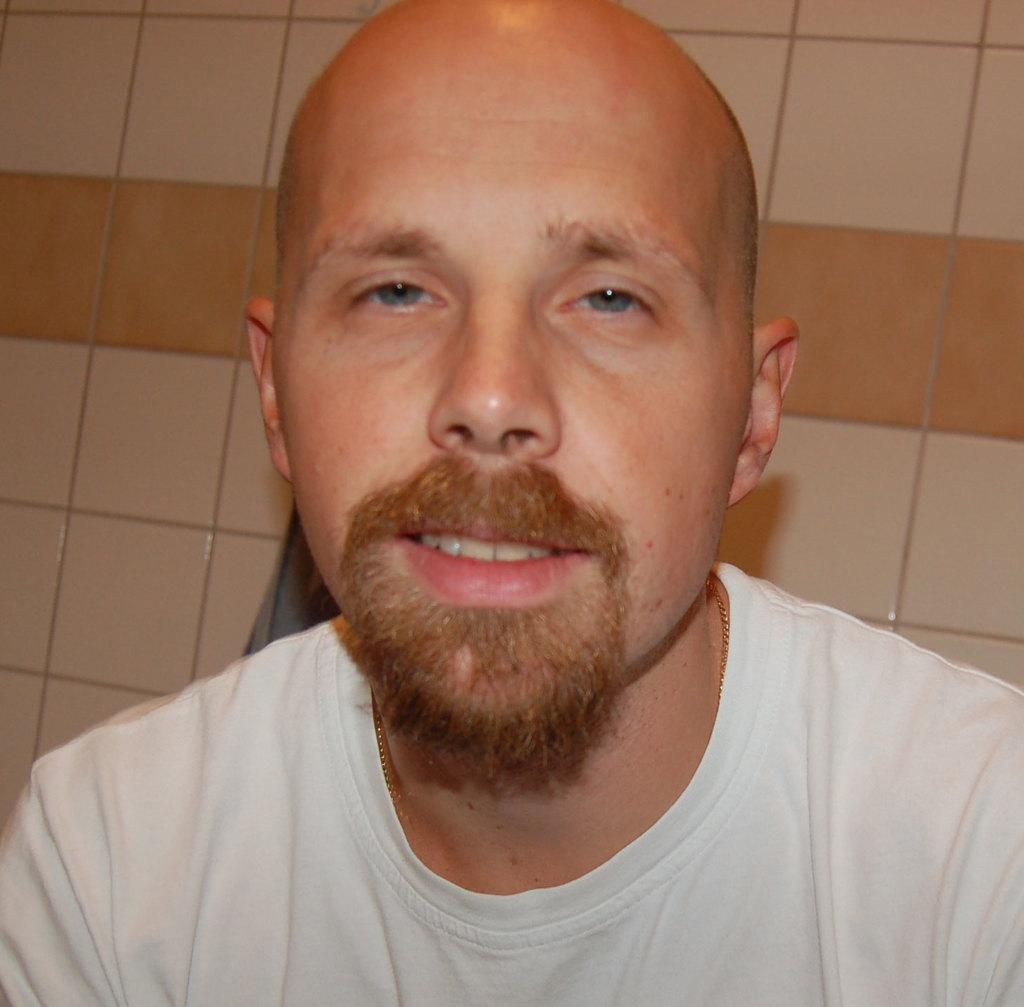What is the main subject of the image? There is a man in the image. What type of jam is the owl eating in the image? There is no owl or jam present in the image; it only features a man. 